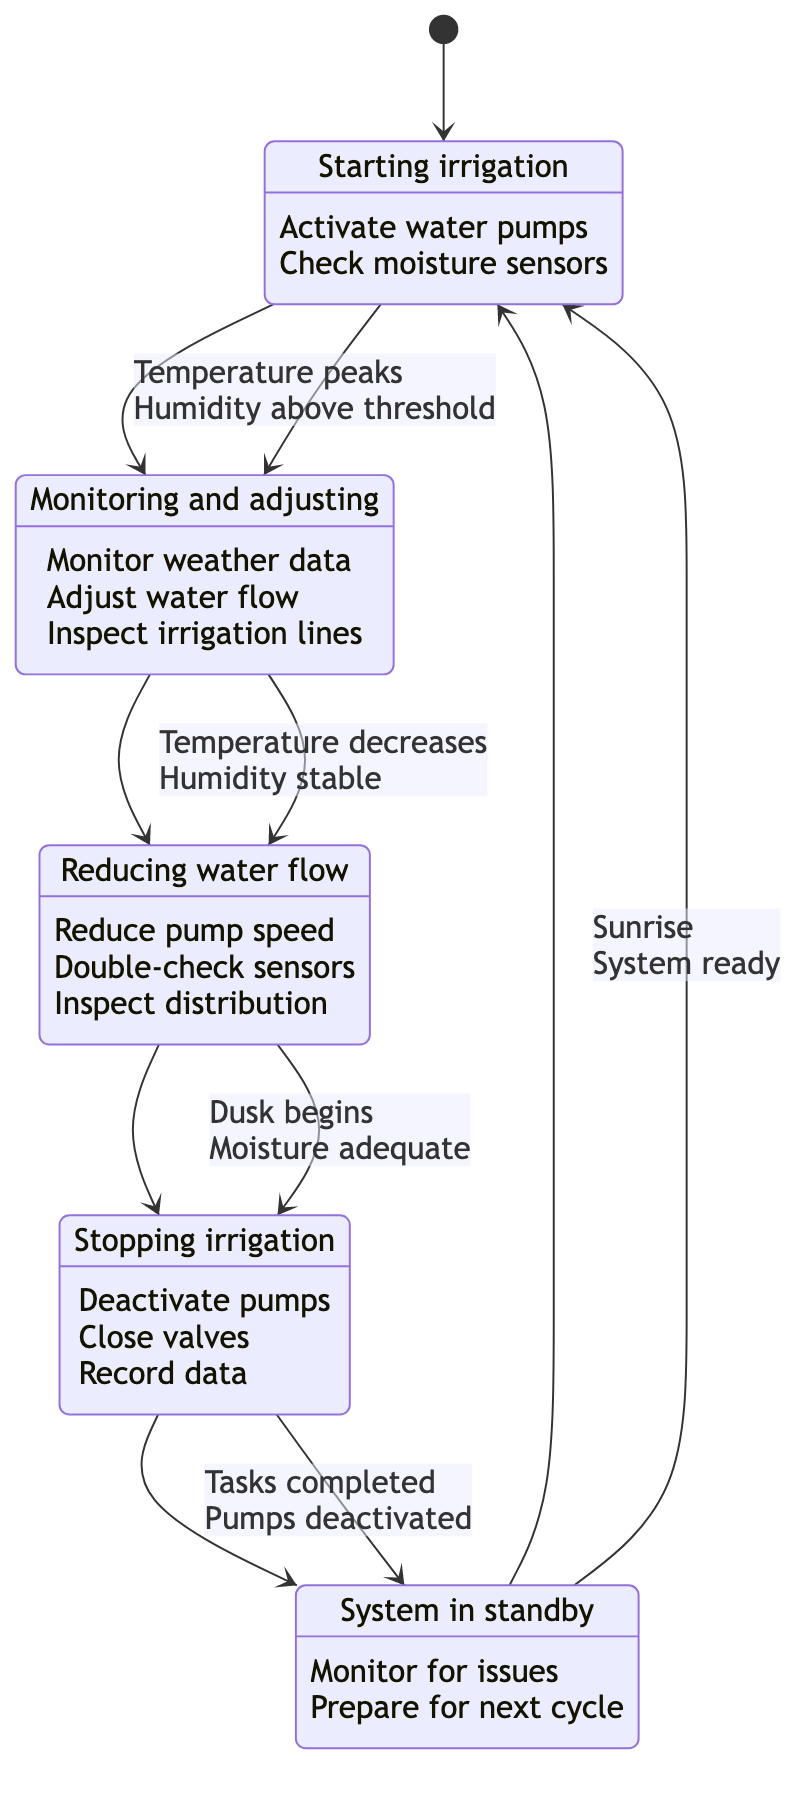What are the states in this irrigation system? The diagram lists five states: Morning, Early Afternoon, Late Afternoon, Evening, and Night. These states represent different phases of the irrigation cycle throughout the day.
Answer: Morning, Early Afternoon, Late Afternoon, Evening, Night How many actions are in the Morning state? The Morning state contains two actions: "Activate water pumps" and "Check moisture sensors." Thus, the total number of actions is two.
Answer: 2 What triggers the transition from Early Afternoon to Late Afternoon? The transition is triggered when "Temperature starts to decrease." This indicates a shift in the day's temperature dynamics that influences irrigation management.
Answer: Temperature starts to decrease What condition must be met for the transition from Late Afternoon to Evening? The condition that needs to be met is "Moisture level adequate." This ensures that irrigation practices are optimized based on available moisture levels before stopping irrigation.
Answer: Moisture level adequate Which state follows Evening in the irrigation process? The state that follows Evening is Night. This occurs after all activities related to irrigation have been completed for the day.
Answer: Night What actions are taken during the Night state? During the Night state, three actions are performed: "Set system to standby," "Monitor for any issues," and "Prepare for next cycle." This prepares the system for the next day's operations.
Answer: Set system to standby, Monitor for any issues, Prepare for next cycle How many transitions occur in total throughout the day? The diagram indicates a total of four transitions between the states: Morning to Early Afternoon, Early Afternoon to Late Afternoon, Late Afternoon to Evening, and Evening to Night.
Answer: 4 What is the role of moisture sensors in the system? Moisture sensors are checked in both the Morning and Late Afternoon states. They play a critical role in determining the adequacy of moisture levels and ensuring effective irrigation management.
Answer: Check moisture sensors Under what condition does the irrigation system move from Night to Morning? The system transitions from Night to Morning when "Sunrise" occurs, signifying the start of a new irrigation cycle after nightfall.
Answer: Sunrise 